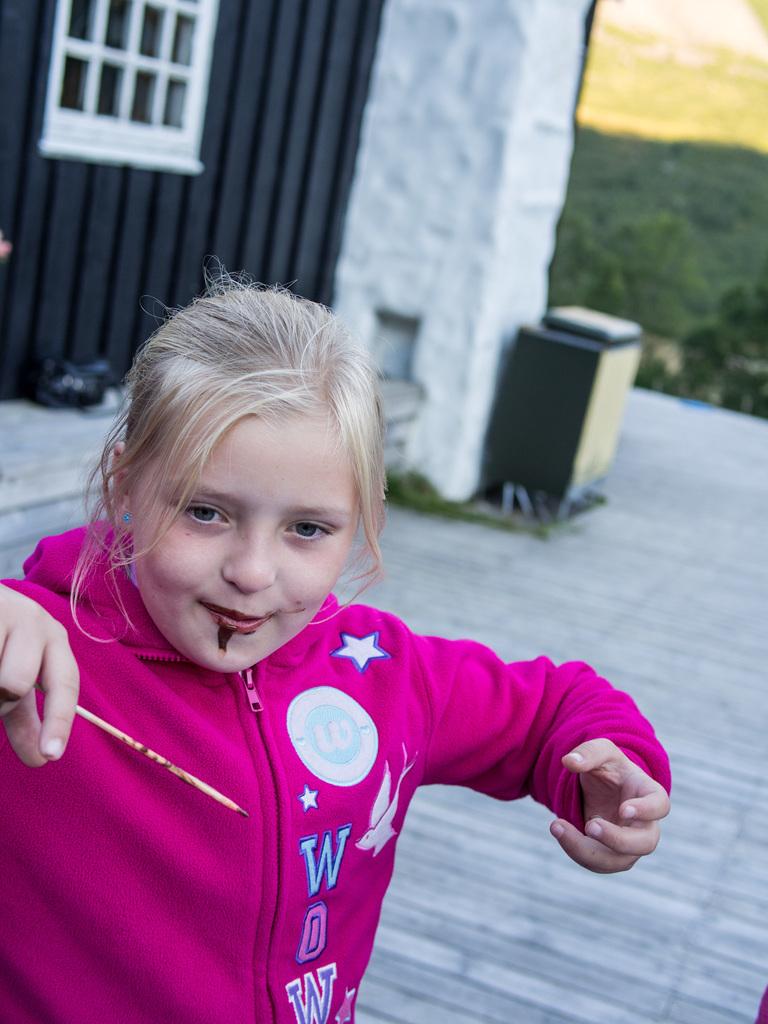What dose the girls shirt say?
Provide a succinct answer. Wow. What is the blue letter on top?
Your answer should be very brief. W. 